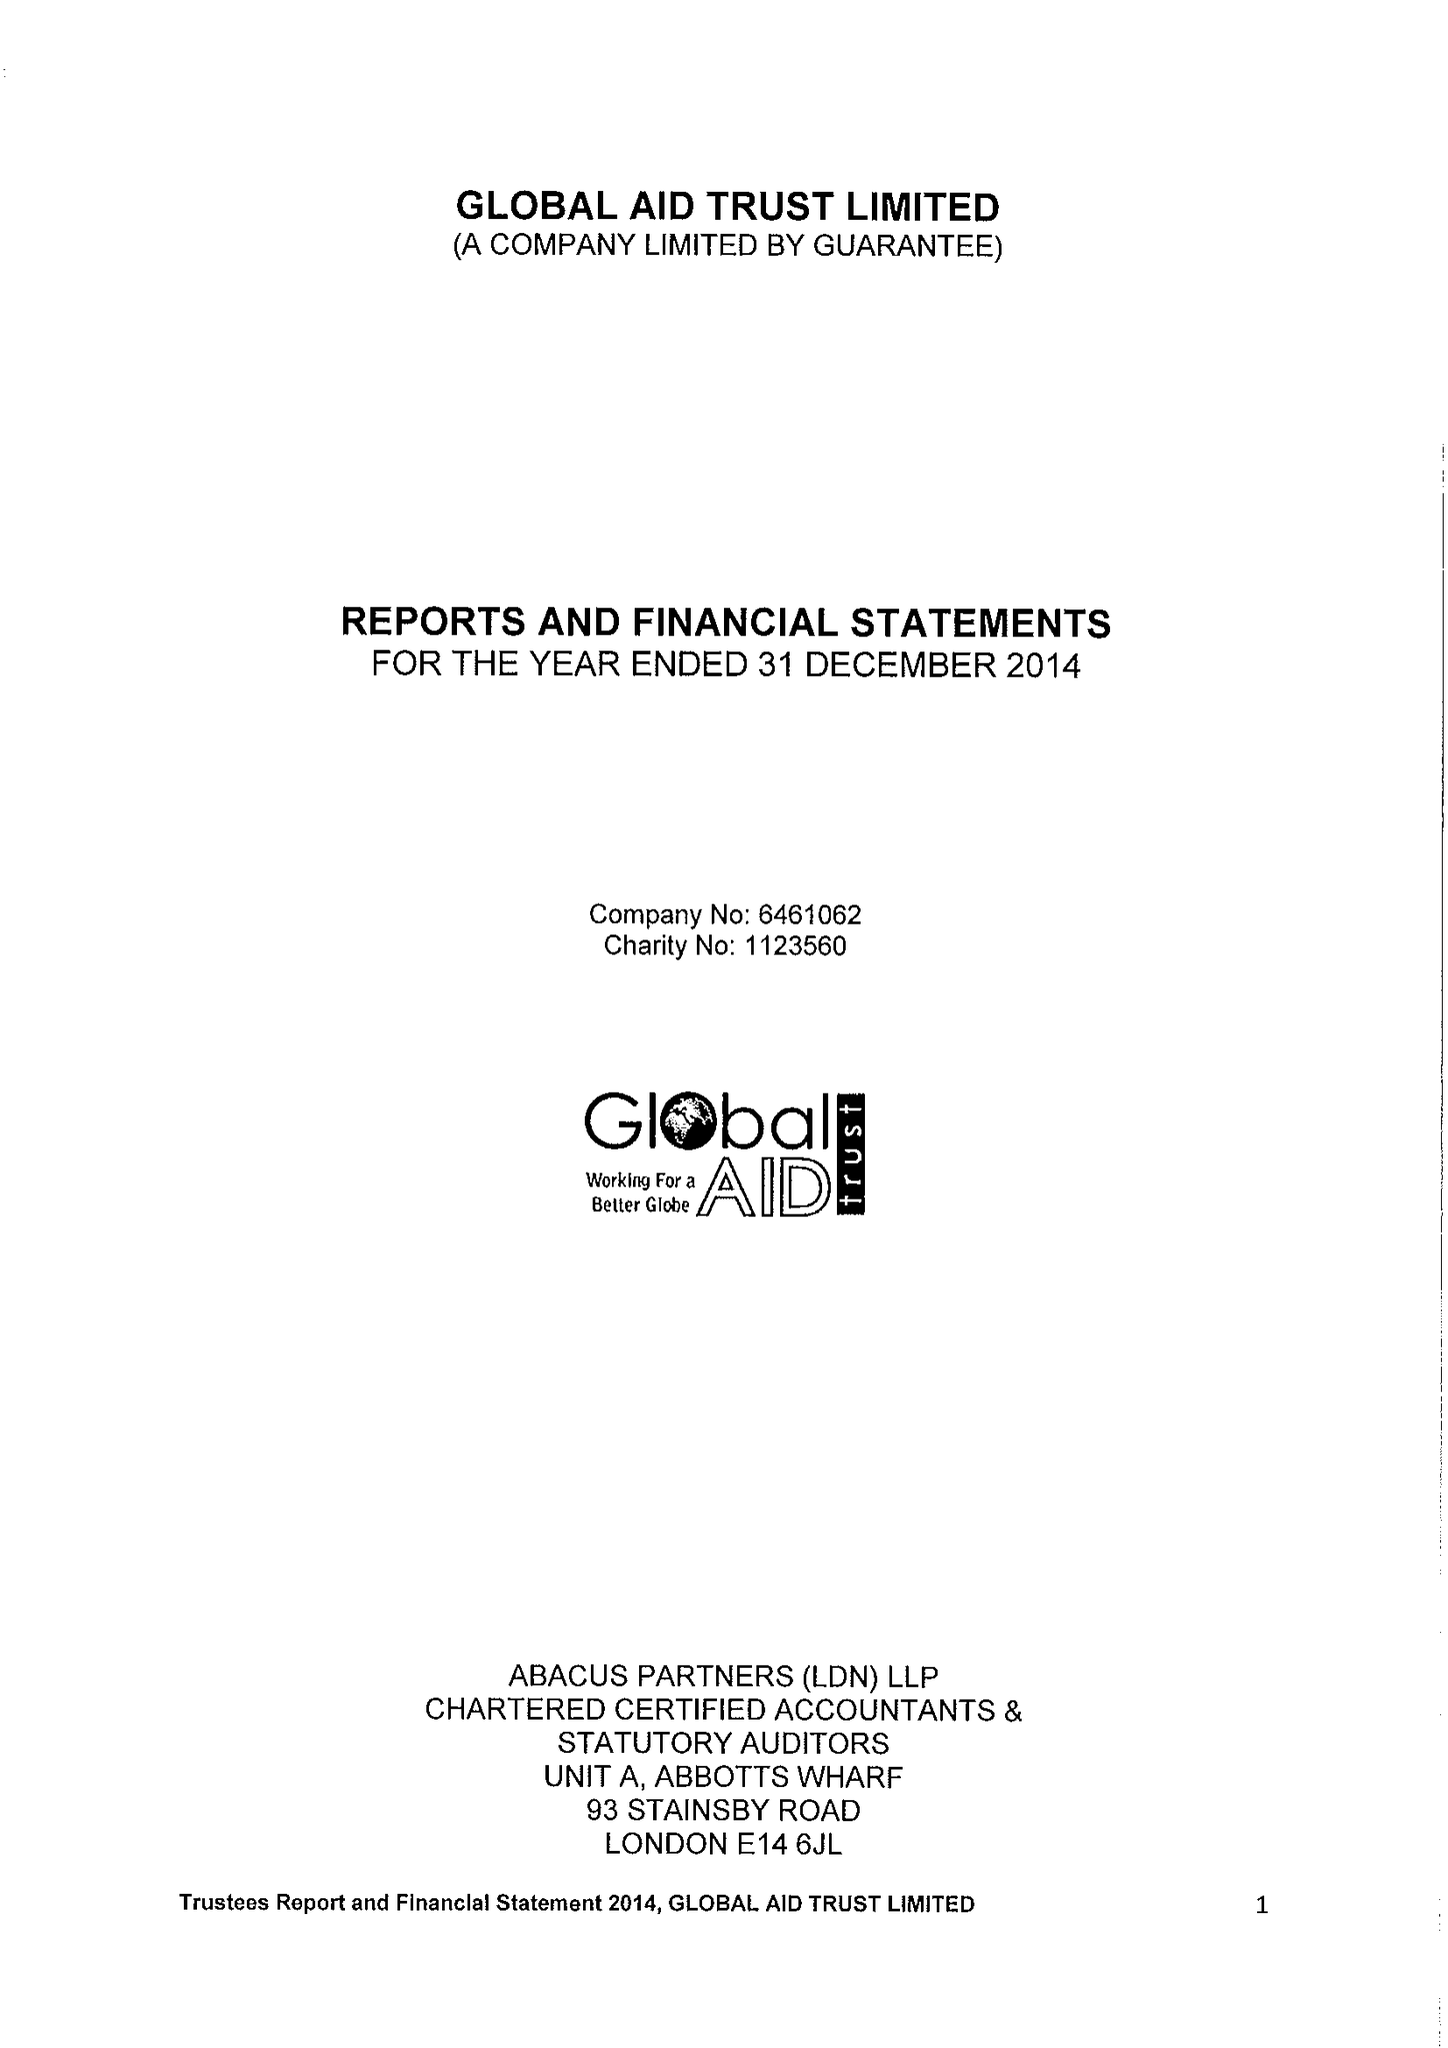What is the value for the income_annually_in_british_pounds?
Answer the question using a single word or phrase. 730324.00 